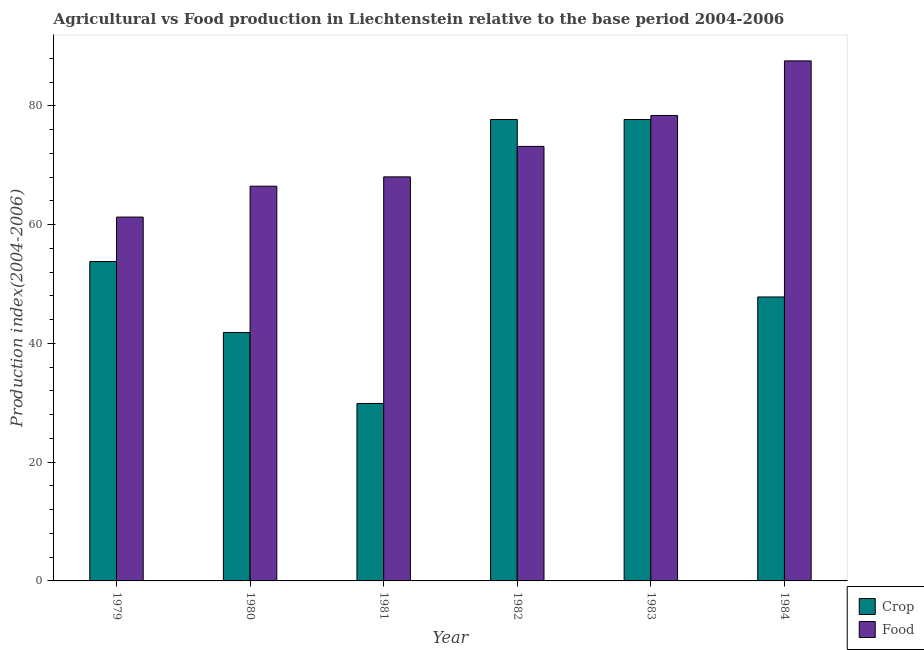How many different coloured bars are there?
Your answer should be compact. 2. Are the number of bars per tick equal to the number of legend labels?
Make the answer very short. Yes. Are the number of bars on each tick of the X-axis equal?
Ensure brevity in your answer.  Yes. How many bars are there on the 5th tick from the left?
Your answer should be very brief. 2. What is the label of the 3rd group of bars from the left?
Make the answer very short. 1981. What is the crop production index in 1984?
Make the answer very short. 47.81. Across all years, what is the maximum food production index?
Give a very brief answer. 87.56. Across all years, what is the minimum crop production index?
Ensure brevity in your answer.  29.88. In which year was the crop production index minimum?
Offer a very short reply. 1981. What is the total food production index in the graph?
Give a very brief answer. 434.84. What is the difference between the food production index in 1979 and that in 1981?
Keep it short and to the point. -6.77. What is the difference between the food production index in 1979 and the crop production index in 1984?
Provide a short and direct response. -26.3. What is the average food production index per year?
Provide a succinct answer. 72.47. In the year 1980, what is the difference between the crop production index and food production index?
Keep it short and to the point. 0. What is the ratio of the food production index in 1980 to that in 1983?
Give a very brief answer. 0.85. Is the crop production index in 1980 less than that in 1983?
Your answer should be compact. Yes. Is the difference between the crop production index in 1979 and 1983 greater than the difference between the food production index in 1979 and 1983?
Keep it short and to the point. No. What is the difference between the highest and the second highest food production index?
Offer a very short reply. 9.19. What is the difference between the highest and the lowest food production index?
Your answer should be compact. 26.3. Is the sum of the crop production index in 1979 and 1982 greater than the maximum food production index across all years?
Keep it short and to the point. Yes. What does the 1st bar from the left in 1983 represents?
Your answer should be compact. Crop. What does the 2nd bar from the right in 1984 represents?
Provide a succinct answer. Crop. How many years are there in the graph?
Offer a very short reply. 6. What is the difference between two consecutive major ticks on the Y-axis?
Provide a short and direct response. 20. Are the values on the major ticks of Y-axis written in scientific E-notation?
Your answer should be very brief. No. How are the legend labels stacked?
Ensure brevity in your answer.  Vertical. What is the title of the graph?
Offer a very short reply. Agricultural vs Food production in Liechtenstein relative to the base period 2004-2006. What is the label or title of the Y-axis?
Offer a terse response. Production index(2004-2006). What is the Production index(2004-2006) of Crop in 1979?
Provide a succinct answer. 53.78. What is the Production index(2004-2006) in Food in 1979?
Ensure brevity in your answer.  61.26. What is the Production index(2004-2006) in Crop in 1980?
Your response must be concise. 41.83. What is the Production index(2004-2006) of Food in 1980?
Provide a succinct answer. 66.46. What is the Production index(2004-2006) of Crop in 1981?
Provide a short and direct response. 29.88. What is the Production index(2004-2006) of Food in 1981?
Offer a terse response. 68.03. What is the Production index(2004-2006) in Crop in 1982?
Your response must be concise. 77.69. What is the Production index(2004-2006) of Food in 1982?
Offer a terse response. 73.16. What is the Production index(2004-2006) of Crop in 1983?
Keep it short and to the point. 77.69. What is the Production index(2004-2006) of Food in 1983?
Keep it short and to the point. 78.37. What is the Production index(2004-2006) of Crop in 1984?
Give a very brief answer. 47.81. What is the Production index(2004-2006) in Food in 1984?
Your answer should be compact. 87.56. Across all years, what is the maximum Production index(2004-2006) of Crop?
Offer a very short reply. 77.69. Across all years, what is the maximum Production index(2004-2006) in Food?
Make the answer very short. 87.56. Across all years, what is the minimum Production index(2004-2006) of Crop?
Your answer should be compact. 29.88. Across all years, what is the minimum Production index(2004-2006) in Food?
Give a very brief answer. 61.26. What is the total Production index(2004-2006) of Crop in the graph?
Keep it short and to the point. 328.68. What is the total Production index(2004-2006) of Food in the graph?
Ensure brevity in your answer.  434.84. What is the difference between the Production index(2004-2006) of Crop in 1979 and that in 1980?
Provide a short and direct response. 11.95. What is the difference between the Production index(2004-2006) of Food in 1979 and that in 1980?
Provide a succinct answer. -5.2. What is the difference between the Production index(2004-2006) in Crop in 1979 and that in 1981?
Ensure brevity in your answer.  23.9. What is the difference between the Production index(2004-2006) in Food in 1979 and that in 1981?
Your answer should be compact. -6.77. What is the difference between the Production index(2004-2006) of Crop in 1979 and that in 1982?
Your answer should be compact. -23.91. What is the difference between the Production index(2004-2006) in Food in 1979 and that in 1982?
Your answer should be compact. -11.9. What is the difference between the Production index(2004-2006) of Crop in 1979 and that in 1983?
Offer a terse response. -23.91. What is the difference between the Production index(2004-2006) of Food in 1979 and that in 1983?
Provide a short and direct response. -17.11. What is the difference between the Production index(2004-2006) in Crop in 1979 and that in 1984?
Provide a succinct answer. 5.97. What is the difference between the Production index(2004-2006) in Food in 1979 and that in 1984?
Provide a succinct answer. -26.3. What is the difference between the Production index(2004-2006) of Crop in 1980 and that in 1981?
Your answer should be compact. 11.95. What is the difference between the Production index(2004-2006) of Food in 1980 and that in 1981?
Provide a short and direct response. -1.57. What is the difference between the Production index(2004-2006) of Crop in 1980 and that in 1982?
Offer a terse response. -35.86. What is the difference between the Production index(2004-2006) of Food in 1980 and that in 1982?
Provide a short and direct response. -6.7. What is the difference between the Production index(2004-2006) of Crop in 1980 and that in 1983?
Your answer should be very brief. -35.86. What is the difference between the Production index(2004-2006) in Food in 1980 and that in 1983?
Offer a terse response. -11.91. What is the difference between the Production index(2004-2006) of Crop in 1980 and that in 1984?
Offer a terse response. -5.98. What is the difference between the Production index(2004-2006) in Food in 1980 and that in 1984?
Ensure brevity in your answer.  -21.1. What is the difference between the Production index(2004-2006) in Crop in 1981 and that in 1982?
Your answer should be compact. -47.81. What is the difference between the Production index(2004-2006) of Food in 1981 and that in 1982?
Provide a short and direct response. -5.13. What is the difference between the Production index(2004-2006) of Crop in 1981 and that in 1983?
Give a very brief answer. -47.81. What is the difference between the Production index(2004-2006) of Food in 1981 and that in 1983?
Keep it short and to the point. -10.34. What is the difference between the Production index(2004-2006) of Crop in 1981 and that in 1984?
Your answer should be very brief. -17.93. What is the difference between the Production index(2004-2006) in Food in 1981 and that in 1984?
Make the answer very short. -19.53. What is the difference between the Production index(2004-2006) in Crop in 1982 and that in 1983?
Keep it short and to the point. 0. What is the difference between the Production index(2004-2006) of Food in 1982 and that in 1983?
Offer a terse response. -5.21. What is the difference between the Production index(2004-2006) in Crop in 1982 and that in 1984?
Your answer should be very brief. 29.88. What is the difference between the Production index(2004-2006) of Food in 1982 and that in 1984?
Your answer should be very brief. -14.4. What is the difference between the Production index(2004-2006) of Crop in 1983 and that in 1984?
Your answer should be compact. 29.88. What is the difference between the Production index(2004-2006) in Food in 1983 and that in 1984?
Give a very brief answer. -9.19. What is the difference between the Production index(2004-2006) of Crop in 1979 and the Production index(2004-2006) of Food in 1980?
Give a very brief answer. -12.68. What is the difference between the Production index(2004-2006) of Crop in 1979 and the Production index(2004-2006) of Food in 1981?
Make the answer very short. -14.25. What is the difference between the Production index(2004-2006) in Crop in 1979 and the Production index(2004-2006) in Food in 1982?
Offer a very short reply. -19.38. What is the difference between the Production index(2004-2006) in Crop in 1979 and the Production index(2004-2006) in Food in 1983?
Your answer should be very brief. -24.59. What is the difference between the Production index(2004-2006) of Crop in 1979 and the Production index(2004-2006) of Food in 1984?
Provide a succinct answer. -33.78. What is the difference between the Production index(2004-2006) of Crop in 1980 and the Production index(2004-2006) of Food in 1981?
Your response must be concise. -26.2. What is the difference between the Production index(2004-2006) of Crop in 1980 and the Production index(2004-2006) of Food in 1982?
Provide a short and direct response. -31.33. What is the difference between the Production index(2004-2006) in Crop in 1980 and the Production index(2004-2006) in Food in 1983?
Keep it short and to the point. -36.54. What is the difference between the Production index(2004-2006) of Crop in 1980 and the Production index(2004-2006) of Food in 1984?
Your answer should be compact. -45.73. What is the difference between the Production index(2004-2006) in Crop in 1981 and the Production index(2004-2006) in Food in 1982?
Give a very brief answer. -43.28. What is the difference between the Production index(2004-2006) in Crop in 1981 and the Production index(2004-2006) in Food in 1983?
Your answer should be compact. -48.49. What is the difference between the Production index(2004-2006) in Crop in 1981 and the Production index(2004-2006) in Food in 1984?
Offer a very short reply. -57.68. What is the difference between the Production index(2004-2006) in Crop in 1982 and the Production index(2004-2006) in Food in 1983?
Ensure brevity in your answer.  -0.68. What is the difference between the Production index(2004-2006) of Crop in 1982 and the Production index(2004-2006) of Food in 1984?
Provide a short and direct response. -9.87. What is the difference between the Production index(2004-2006) in Crop in 1983 and the Production index(2004-2006) in Food in 1984?
Your response must be concise. -9.87. What is the average Production index(2004-2006) in Crop per year?
Your answer should be compact. 54.78. What is the average Production index(2004-2006) of Food per year?
Ensure brevity in your answer.  72.47. In the year 1979, what is the difference between the Production index(2004-2006) of Crop and Production index(2004-2006) of Food?
Offer a very short reply. -7.48. In the year 1980, what is the difference between the Production index(2004-2006) of Crop and Production index(2004-2006) of Food?
Keep it short and to the point. -24.63. In the year 1981, what is the difference between the Production index(2004-2006) of Crop and Production index(2004-2006) of Food?
Ensure brevity in your answer.  -38.15. In the year 1982, what is the difference between the Production index(2004-2006) of Crop and Production index(2004-2006) of Food?
Your response must be concise. 4.53. In the year 1983, what is the difference between the Production index(2004-2006) in Crop and Production index(2004-2006) in Food?
Provide a short and direct response. -0.68. In the year 1984, what is the difference between the Production index(2004-2006) in Crop and Production index(2004-2006) in Food?
Ensure brevity in your answer.  -39.75. What is the ratio of the Production index(2004-2006) in Food in 1979 to that in 1980?
Make the answer very short. 0.92. What is the ratio of the Production index(2004-2006) in Crop in 1979 to that in 1981?
Offer a terse response. 1.8. What is the ratio of the Production index(2004-2006) in Food in 1979 to that in 1981?
Offer a very short reply. 0.9. What is the ratio of the Production index(2004-2006) in Crop in 1979 to that in 1982?
Make the answer very short. 0.69. What is the ratio of the Production index(2004-2006) in Food in 1979 to that in 1982?
Give a very brief answer. 0.84. What is the ratio of the Production index(2004-2006) of Crop in 1979 to that in 1983?
Provide a succinct answer. 0.69. What is the ratio of the Production index(2004-2006) of Food in 1979 to that in 1983?
Keep it short and to the point. 0.78. What is the ratio of the Production index(2004-2006) of Crop in 1979 to that in 1984?
Make the answer very short. 1.12. What is the ratio of the Production index(2004-2006) in Food in 1979 to that in 1984?
Give a very brief answer. 0.7. What is the ratio of the Production index(2004-2006) in Crop in 1980 to that in 1981?
Ensure brevity in your answer.  1.4. What is the ratio of the Production index(2004-2006) in Food in 1980 to that in 1981?
Provide a short and direct response. 0.98. What is the ratio of the Production index(2004-2006) of Crop in 1980 to that in 1982?
Provide a short and direct response. 0.54. What is the ratio of the Production index(2004-2006) in Food in 1980 to that in 1982?
Your response must be concise. 0.91. What is the ratio of the Production index(2004-2006) in Crop in 1980 to that in 1983?
Offer a very short reply. 0.54. What is the ratio of the Production index(2004-2006) in Food in 1980 to that in 1983?
Your response must be concise. 0.85. What is the ratio of the Production index(2004-2006) in Crop in 1980 to that in 1984?
Make the answer very short. 0.87. What is the ratio of the Production index(2004-2006) in Food in 1980 to that in 1984?
Ensure brevity in your answer.  0.76. What is the ratio of the Production index(2004-2006) in Crop in 1981 to that in 1982?
Provide a succinct answer. 0.38. What is the ratio of the Production index(2004-2006) in Food in 1981 to that in 1982?
Provide a succinct answer. 0.93. What is the ratio of the Production index(2004-2006) of Crop in 1981 to that in 1983?
Provide a short and direct response. 0.38. What is the ratio of the Production index(2004-2006) of Food in 1981 to that in 1983?
Your answer should be very brief. 0.87. What is the ratio of the Production index(2004-2006) in Crop in 1981 to that in 1984?
Provide a short and direct response. 0.62. What is the ratio of the Production index(2004-2006) in Food in 1981 to that in 1984?
Provide a succinct answer. 0.78. What is the ratio of the Production index(2004-2006) in Food in 1982 to that in 1983?
Provide a short and direct response. 0.93. What is the ratio of the Production index(2004-2006) in Crop in 1982 to that in 1984?
Your response must be concise. 1.62. What is the ratio of the Production index(2004-2006) in Food in 1982 to that in 1984?
Offer a very short reply. 0.84. What is the ratio of the Production index(2004-2006) in Crop in 1983 to that in 1984?
Keep it short and to the point. 1.62. What is the ratio of the Production index(2004-2006) in Food in 1983 to that in 1984?
Ensure brevity in your answer.  0.9. What is the difference between the highest and the second highest Production index(2004-2006) of Crop?
Ensure brevity in your answer.  0. What is the difference between the highest and the second highest Production index(2004-2006) in Food?
Your answer should be very brief. 9.19. What is the difference between the highest and the lowest Production index(2004-2006) in Crop?
Keep it short and to the point. 47.81. What is the difference between the highest and the lowest Production index(2004-2006) in Food?
Make the answer very short. 26.3. 